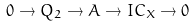Convert formula to latex. <formula><loc_0><loc_0><loc_500><loc_500>0 \to Q _ { 2 } \to A \to I C _ { X } \to 0</formula> 